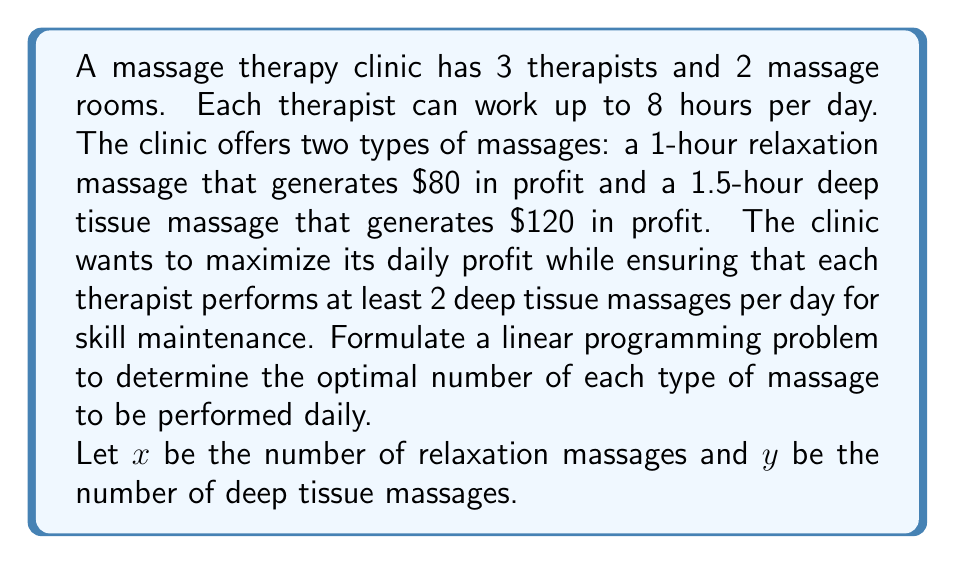Show me your answer to this math problem. To formulate this linear programming problem, we need to define the objective function and constraints:

1. Objective function:
Maximize profit: $Z = 80x + 120y$

2. Constraints:
a) Time constraint:
Total time available = 3 therapists × 8 hours = 24 hours
Time used = $1x + 1.5y \leq 24$

b) Room constraint:
With 2 rooms and operating hours from 9 AM to 5 PM (8 hours):
Total available room-hours = 2 × 8 = 16
$x + y \leq 16$ (since each massage occupies one room)

c) Skill maintenance constraint:
Each therapist must perform at least 2 deep tissue massages:
$y \geq 6$ (3 therapists × 2 massages)

d) Non-negativity constraints:
$x \geq 0$, $y \geq 0$

Therefore, the complete linear programming problem is:

Maximize $Z = 80x + 120y$
Subject to:
$$\begin{align*}
x + 1.5y &\leq 24 \\
x + y &\leq 16 \\
y &\geq 6 \\
x, y &\geq 0
\end{align*}$$
Answer: The linear programming problem to maximize daily profit is:

Maximize $Z = 80x + 120y$
Subject to:
$$\begin{align*}
x + 1.5y &\leq 24 \\
x + y &\leq 16 \\
y &\geq 6 \\
x, y &\geq 0
\end{align*}$$

Where $x$ is the number of relaxation massages and $y$ is the number of deep tissue massages. 